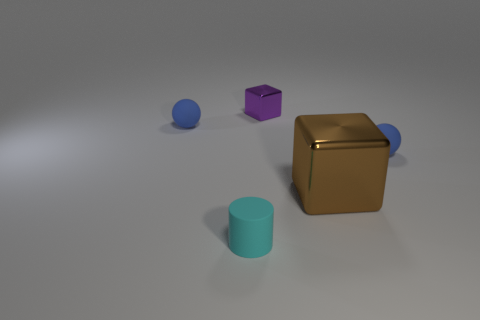Add 4 cyan matte objects. How many objects exist? 9 Subtract all balls. How many objects are left? 3 Add 5 small purple shiny blocks. How many small purple shiny blocks are left? 6 Add 3 blue shiny objects. How many blue shiny objects exist? 3 Subtract 0 gray cylinders. How many objects are left? 5 Subtract all blocks. Subtract all big brown matte balls. How many objects are left? 3 